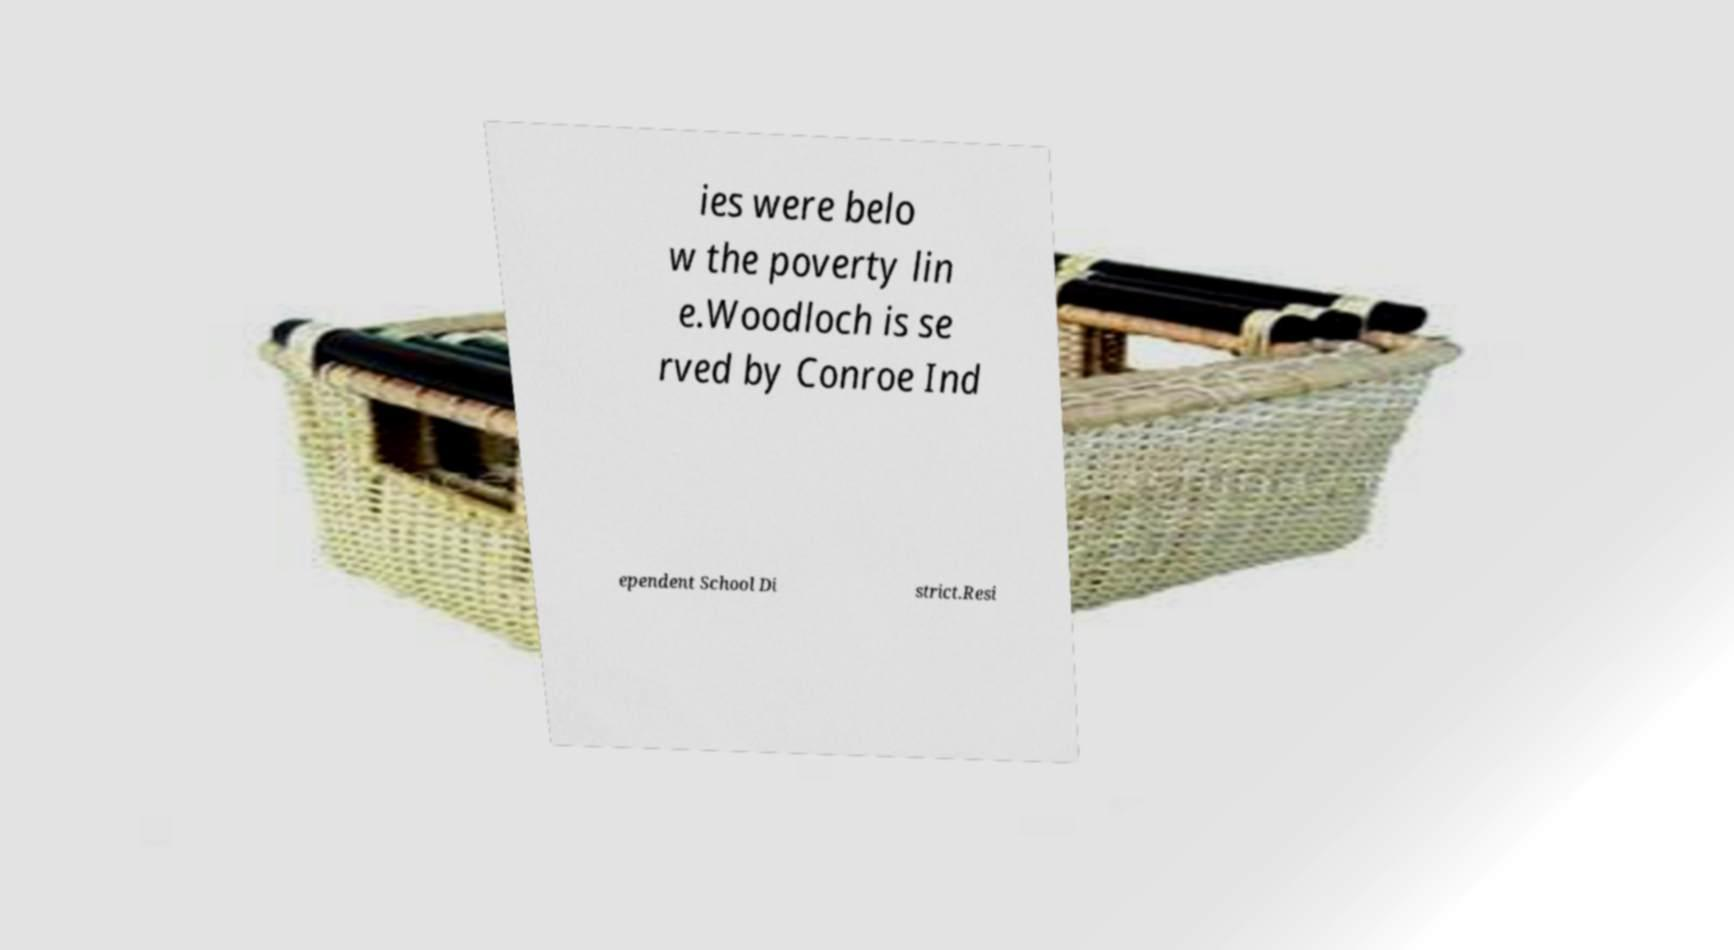There's text embedded in this image that I need extracted. Can you transcribe it verbatim? ies were belo w the poverty lin e.Woodloch is se rved by Conroe Ind ependent School Di strict.Resi 